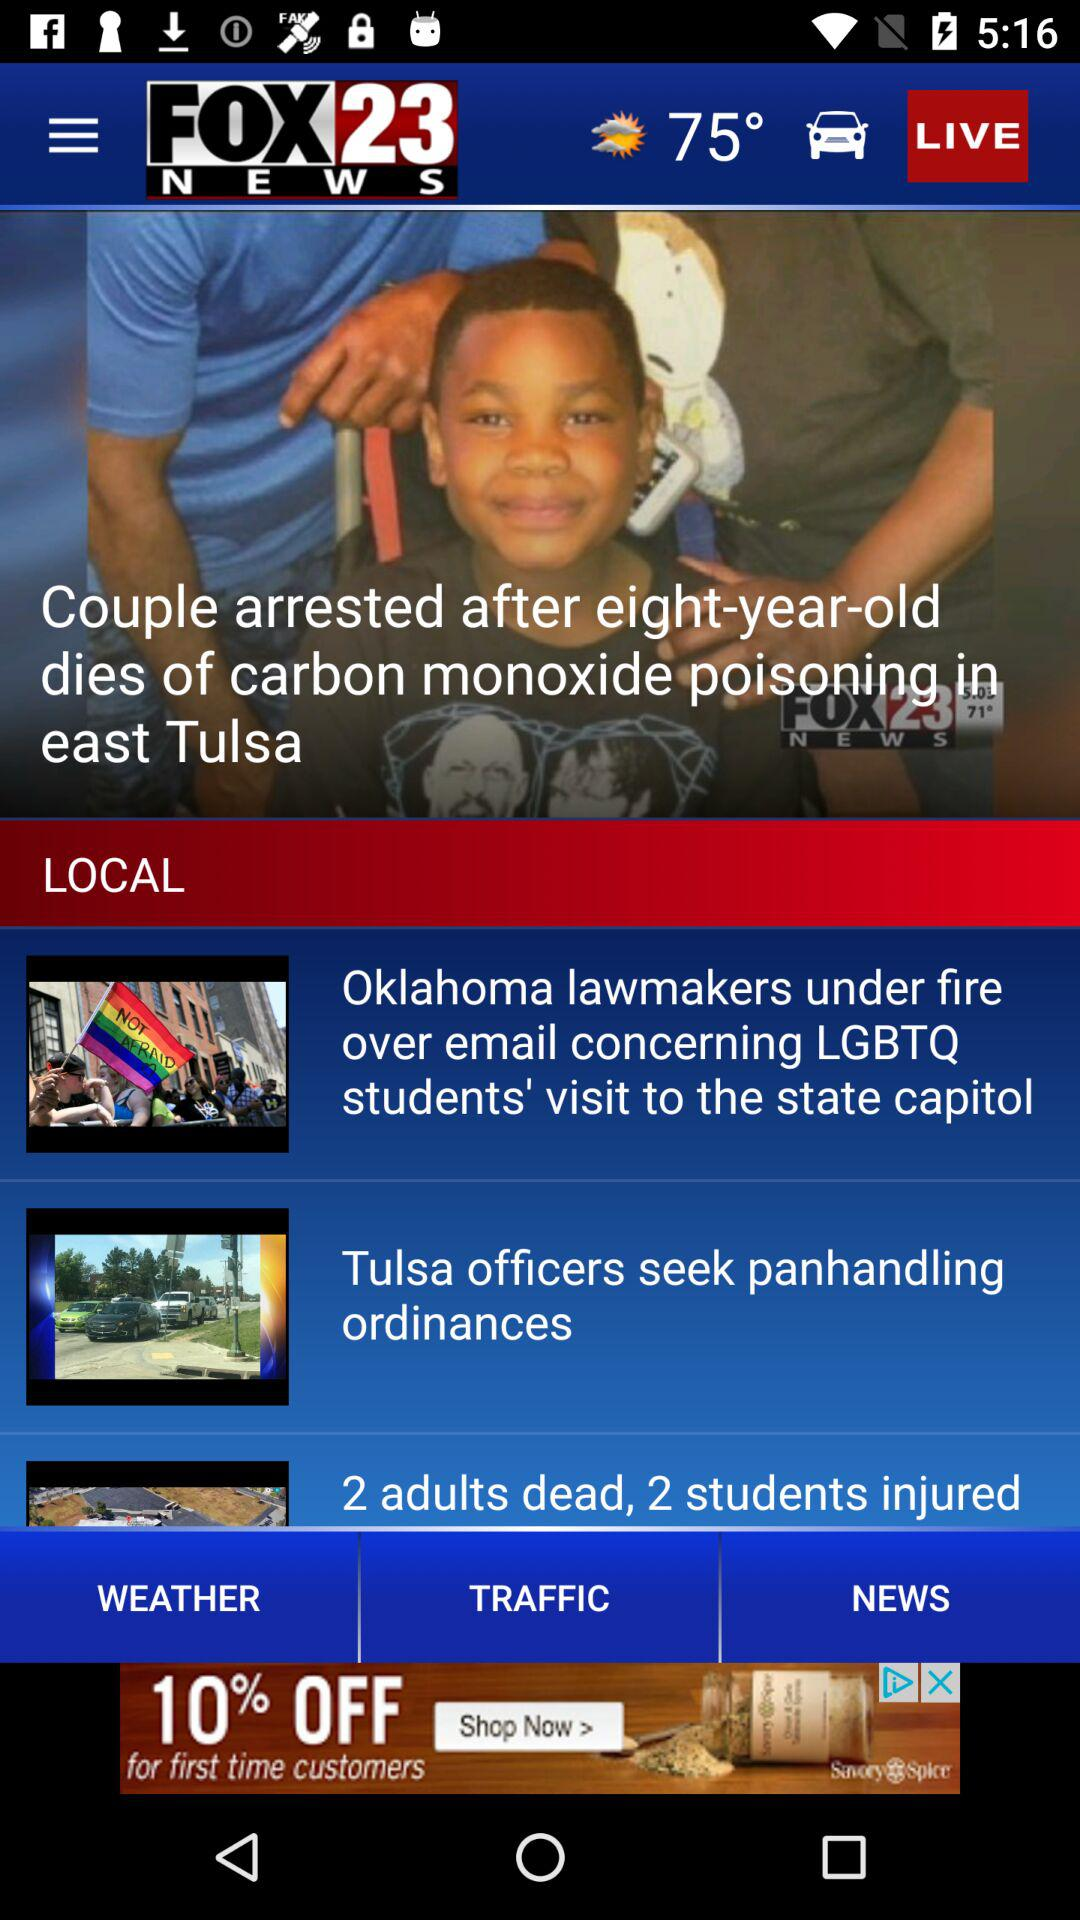What is the headline of the news? The headlines of the news are "Couple arrested after eight-year-old dies of carbon monoxide poisoning in east Tulsa", "Oklahoma lawmakers under fire over email concerning LGBTQ students' visit to the state capitol" and "Tulsa officers seek panhandling ordinances". 